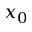<formula> <loc_0><loc_0><loc_500><loc_500>x _ { 0 }</formula> 